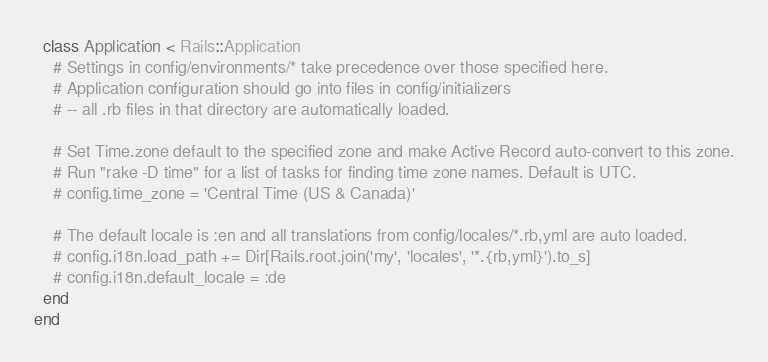<code> <loc_0><loc_0><loc_500><loc_500><_Ruby_>  class Application < Rails::Application
    # Settings in config/environments/* take precedence over those specified here.
    # Application configuration should go into files in config/initializers
    # -- all .rb files in that directory are automatically loaded.

    # Set Time.zone default to the specified zone and make Active Record auto-convert to this zone.
    # Run "rake -D time" for a list of tasks for finding time zone names. Default is UTC.
    # config.time_zone = 'Central Time (US & Canada)'

    # The default locale is :en and all translations from config/locales/*.rb,yml are auto loaded.
    # config.i18n.load_path += Dir[Rails.root.join('my', 'locales', '*.{rb,yml}').to_s]
    # config.i18n.default_locale = :de
  end
end

</code> 